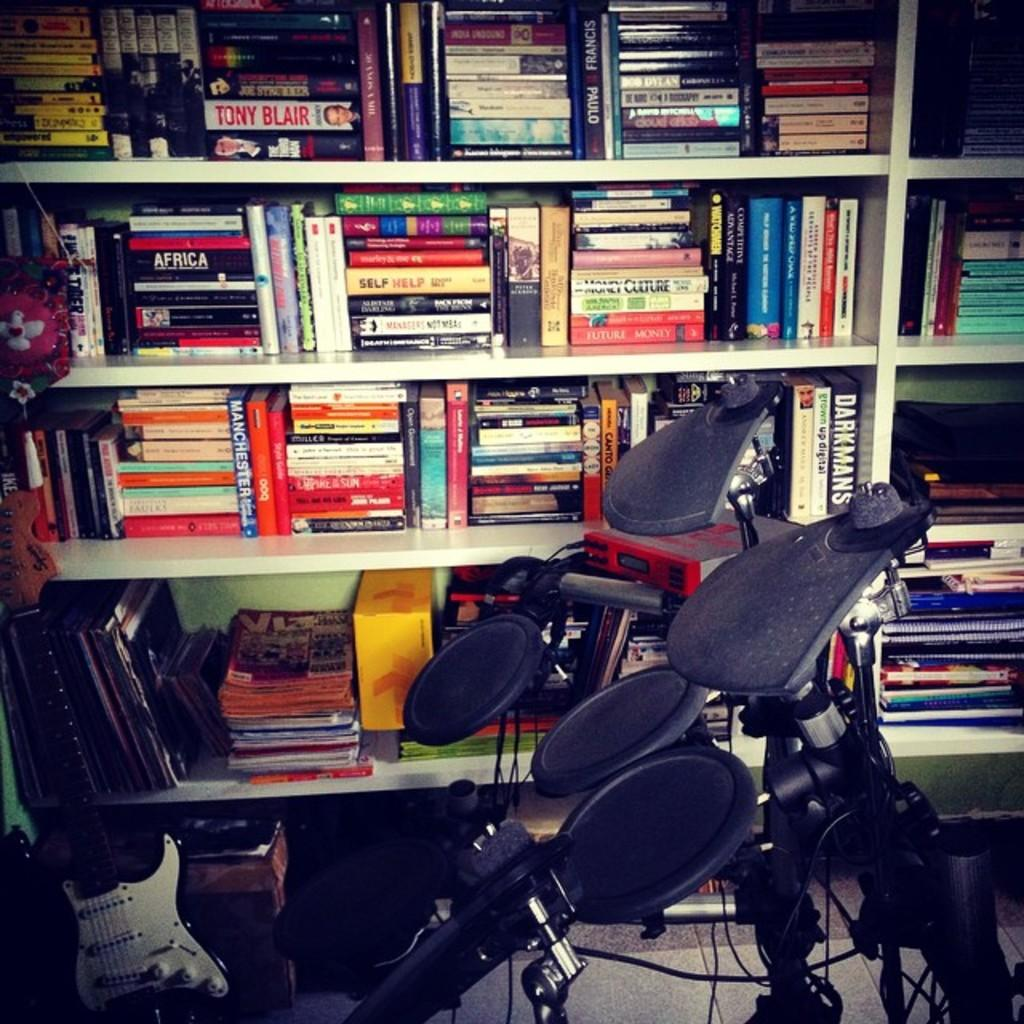<image>
Describe the image concisely. Book shelf that has a book titled AFRICA in front of a drum set. 